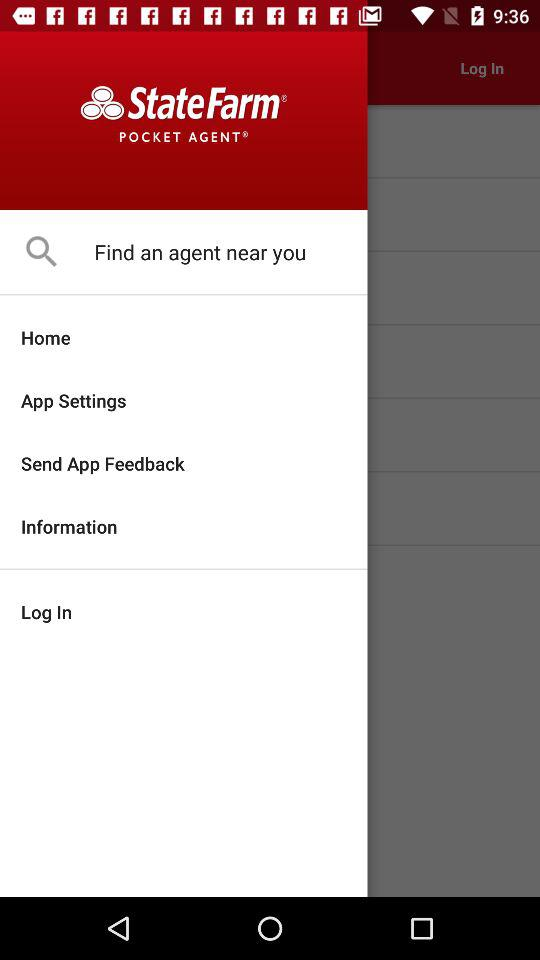What is the user's location?
When the provided information is insufficient, respond with <no answer>. <no answer> 